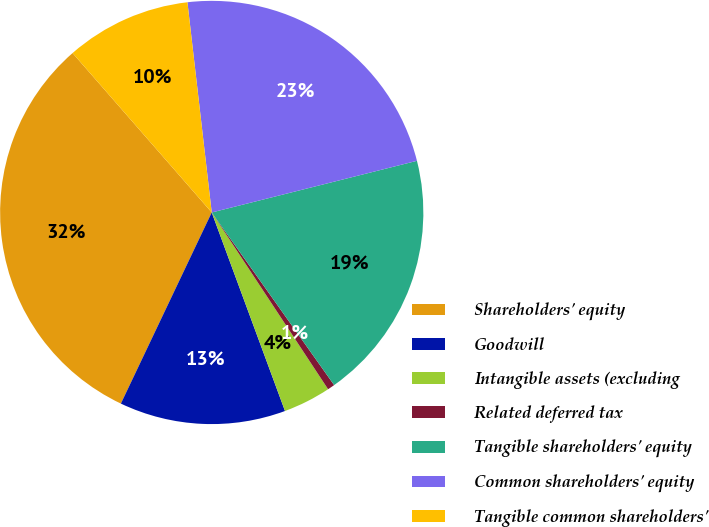<chart> <loc_0><loc_0><loc_500><loc_500><pie_chart><fcel>Shareholders' equity<fcel>Goodwill<fcel>Intangible assets (excluding<fcel>Related deferred tax<fcel>Tangible shareholders' equity<fcel>Common shareholders' equity<fcel>Tangible common shareholders'<nl><fcel>31.52%<fcel>12.69%<fcel>3.64%<fcel>0.55%<fcel>19.11%<fcel>22.91%<fcel>9.59%<nl></chart> 